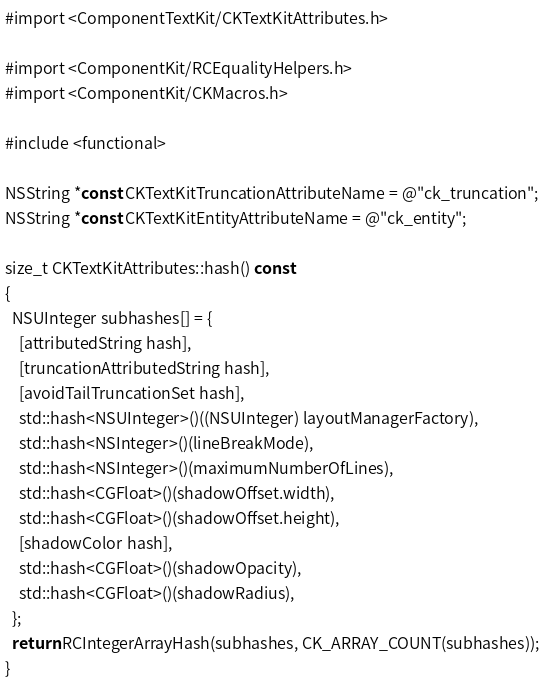Convert code to text. <code><loc_0><loc_0><loc_500><loc_500><_ObjectiveC_>
#import <ComponentTextKit/CKTextKitAttributes.h>

#import <ComponentKit/RCEqualityHelpers.h>
#import <ComponentKit/CKMacros.h>

#include <functional>

NSString *const CKTextKitTruncationAttributeName = @"ck_truncation";
NSString *const CKTextKitEntityAttributeName = @"ck_entity";

size_t CKTextKitAttributes::hash() const
{
  NSUInteger subhashes[] = {
    [attributedString hash],
    [truncationAttributedString hash],
    [avoidTailTruncationSet hash],
    std::hash<NSUInteger>()((NSUInteger) layoutManagerFactory),
    std::hash<NSInteger>()(lineBreakMode),
    std::hash<NSInteger>()(maximumNumberOfLines),
    std::hash<CGFloat>()(shadowOffset.width),
    std::hash<CGFloat>()(shadowOffset.height),
    [shadowColor hash],
    std::hash<CGFloat>()(shadowOpacity),
    std::hash<CGFloat>()(shadowRadius),
  };
  return RCIntegerArrayHash(subhashes, CK_ARRAY_COUNT(subhashes));
}
</code> 